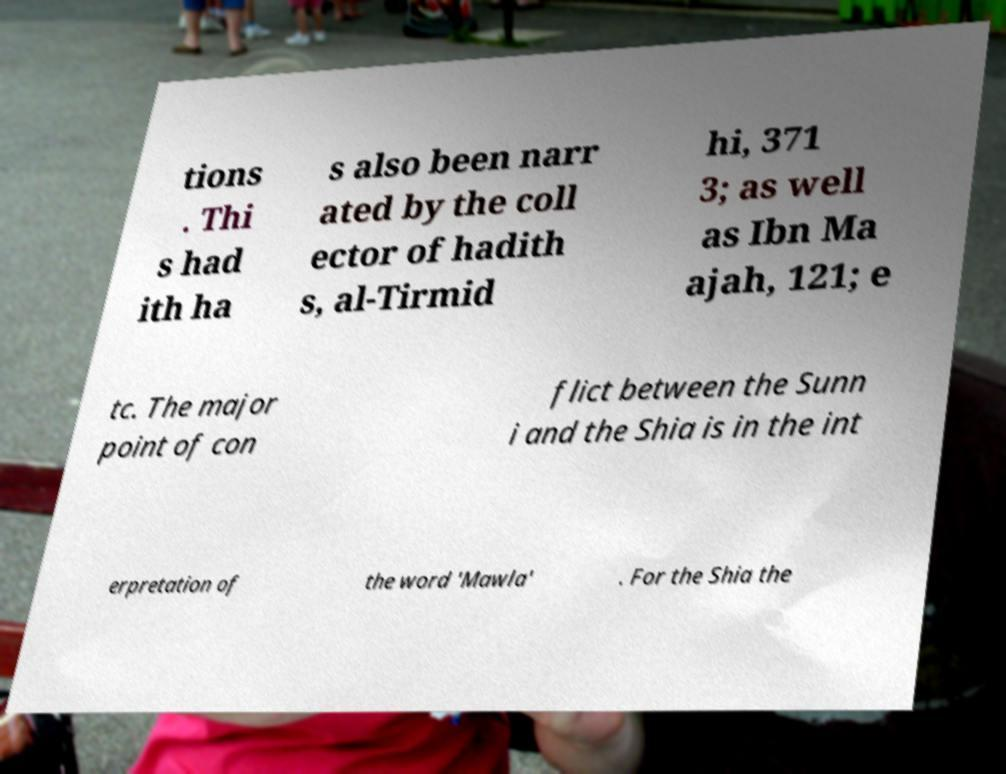Can you accurately transcribe the text from the provided image for me? tions . Thi s had ith ha s also been narr ated by the coll ector of hadith s, al-Tirmid hi, 371 3; as well as Ibn Ma ajah, 121; e tc. The major point of con flict between the Sunn i and the Shia is in the int erpretation of the word 'Mawla' . For the Shia the 